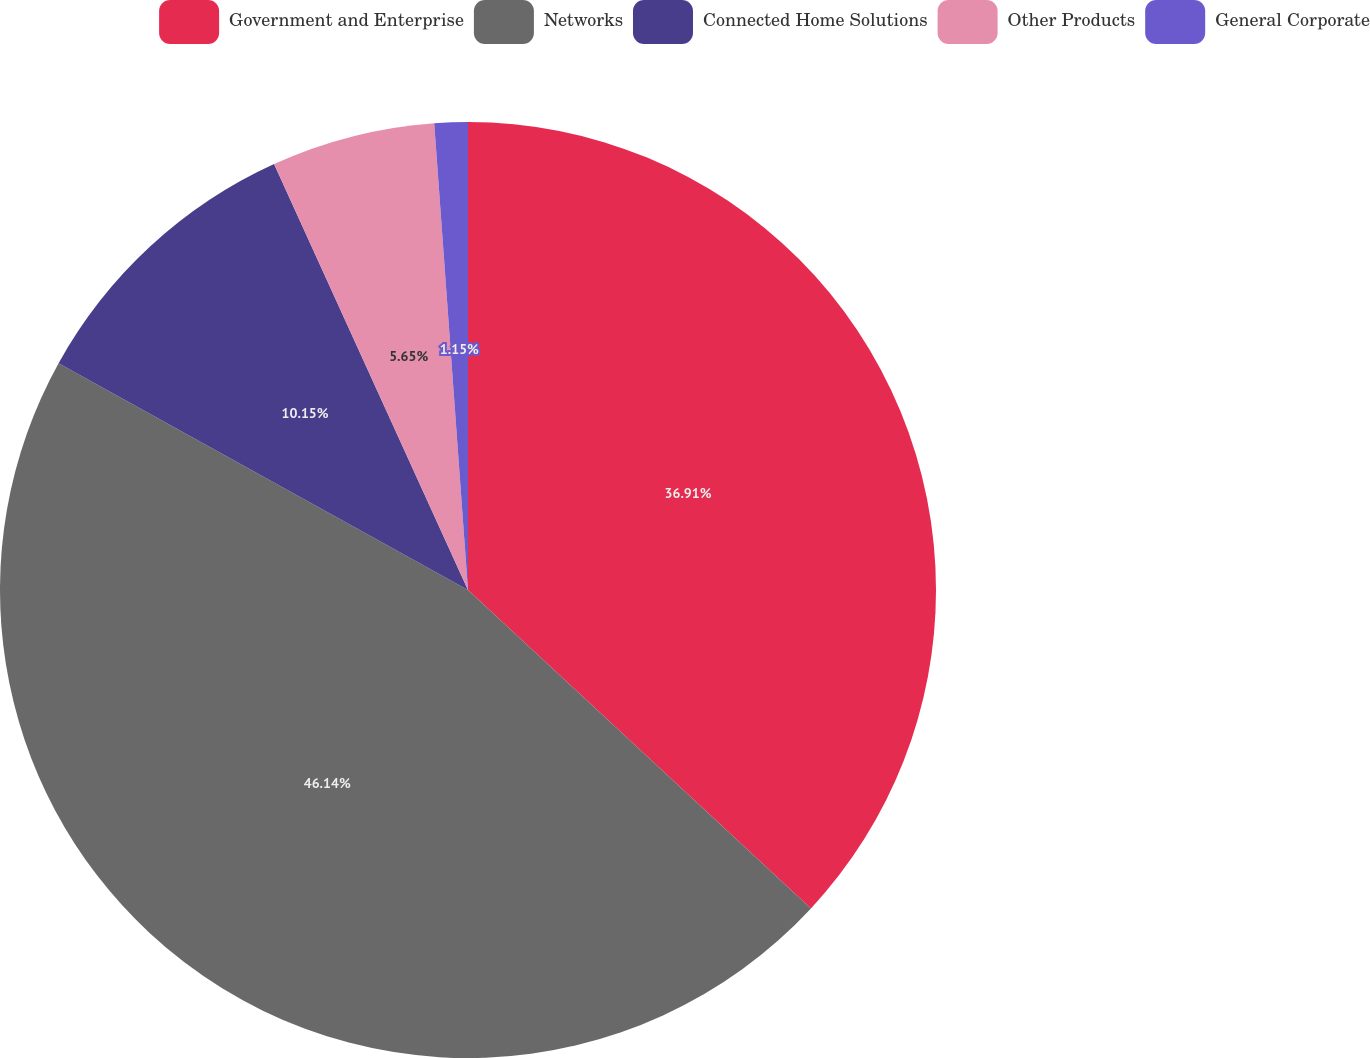<chart> <loc_0><loc_0><loc_500><loc_500><pie_chart><fcel>Government and Enterprise<fcel>Networks<fcel>Connected Home Solutions<fcel>Other Products<fcel>General Corporate<nl><fcel>36.91%<fcel>46.14%<fcel>10.15%<fcel>5.65%<fcel>1.15%<nl></chart> 